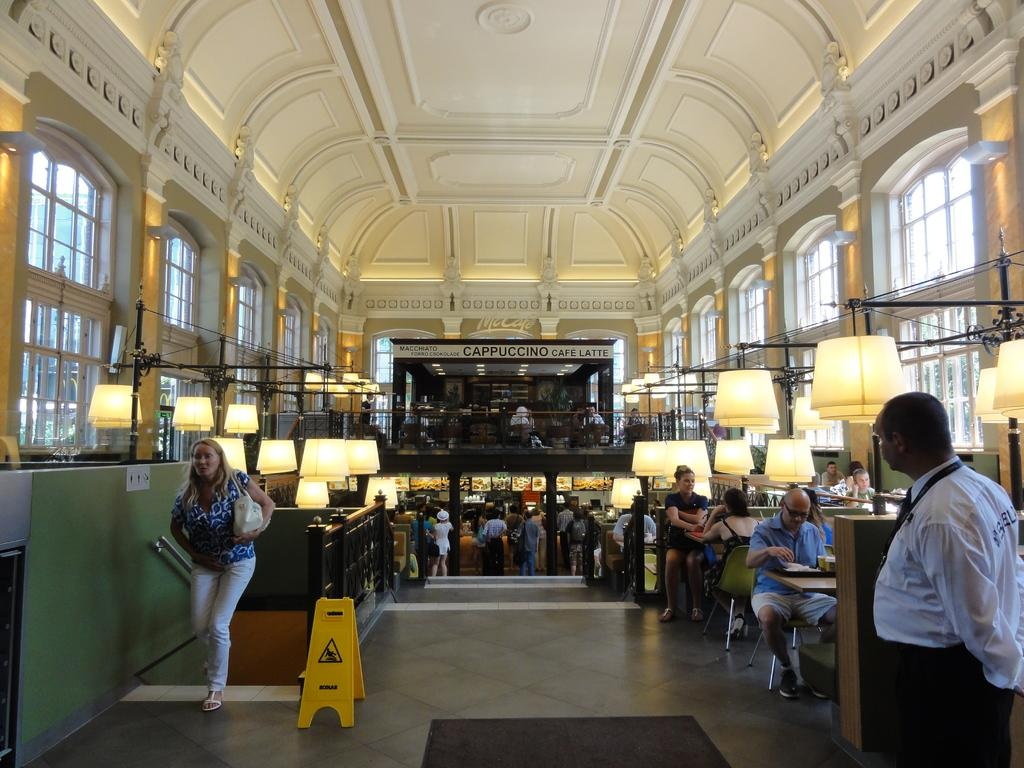What type of location is depicted in the image? The image is an inside view of a building. What are the people in the image doing? The people in the image are standing and sitting. What type of furniture is present in the image? There are chairs and tables in the image. What safety measure is present in the image? There is a caution board in the image. What type of lighting is present in the image? There are lights in the image. What architectural feature is present in the image? There are windows in the image. What type of whip can be seen being used by the people in the image? There is no whip present in the image; the people are standing and sitting in a building. What type of lumber is stacked near the windows in the image? There is no lumber present in the image; the architectural feature near the windows is a caution board. 